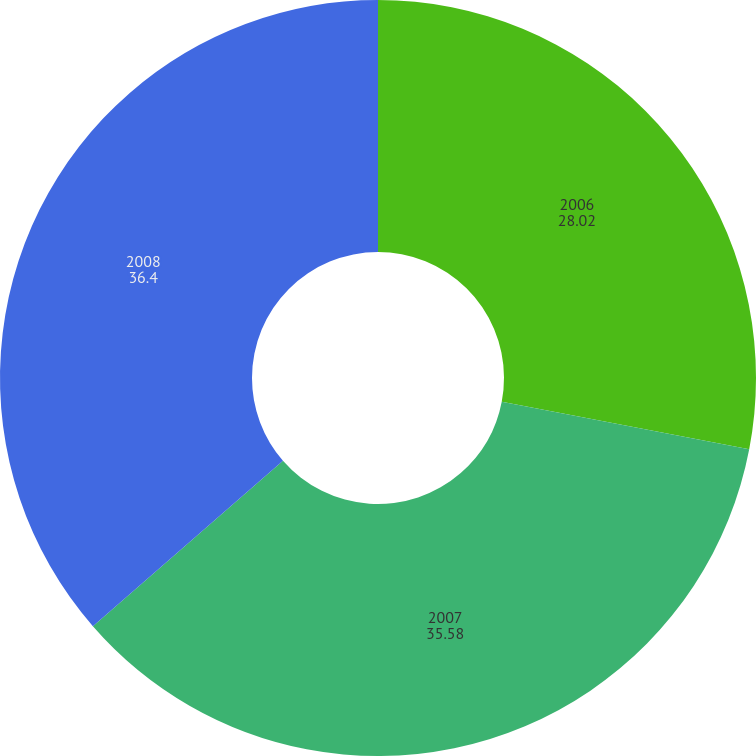Convert chart. <chart><loc_0><loc_0><loc_500><loc_500><pie_chart><fcel>2006<fcel>2007<fcel>2008<nl><fcel>28.02%<fcel>35.58%<fcel>36.4%<nl></chart> 